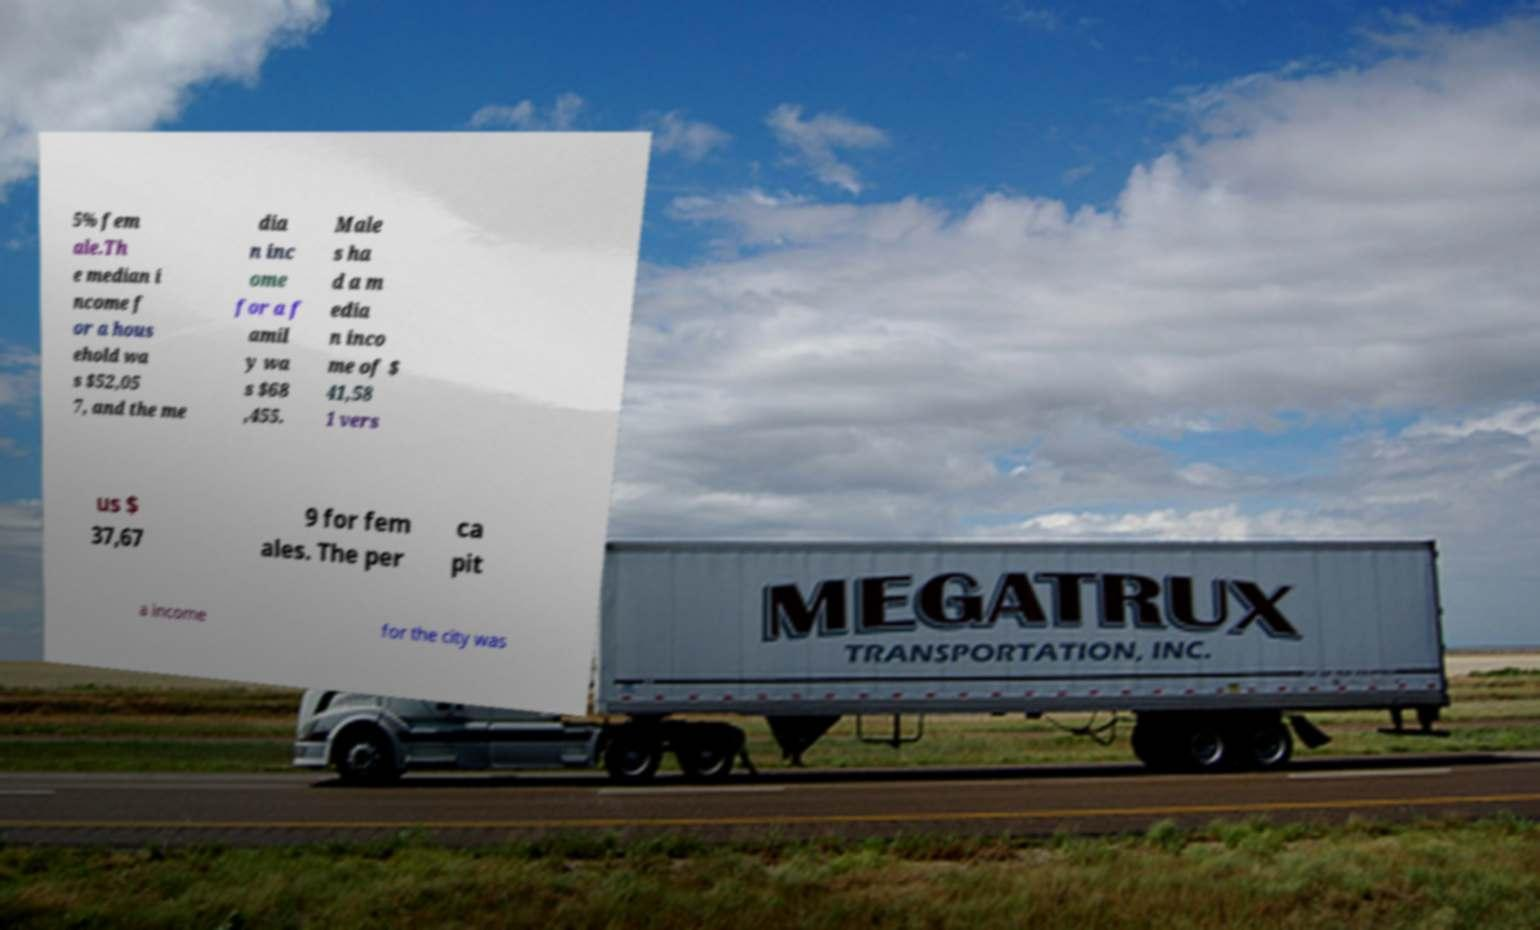Please read and relay the text visible in this image. What does it say? 5% fem ale.Th e median i ncome f or a hous ehold wa s $52,05 7, and the me dia n inc ome for a f amil y wa s $68 ,455. Male s ha d a m edia n inco me of $ 41,58 1 vers us $ 37,67 9 for fem ales. The per ca pit a income for the city was 